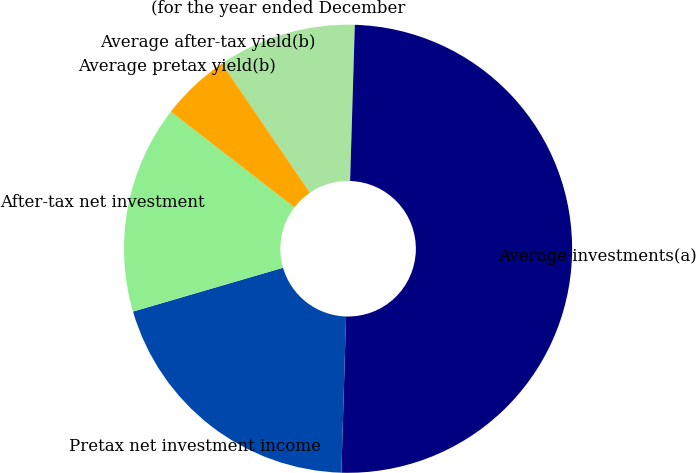<chart> <loc_0><loc_0><loc_500><loc_500><pie_chart><fcel>(for the year ended December<fcel>Average investments(a)<fcel>Pretax net investment income<fcel>After-tax net investment<fcel>Average pretax yield(b)<fcel>Average after-tax yield(b)<nl><fcel>10.0%<fcel>49.99%<fcel>20.0%<fcel>15.0%<fcel>5.0%<fcel>0.0%<nl></chart> 